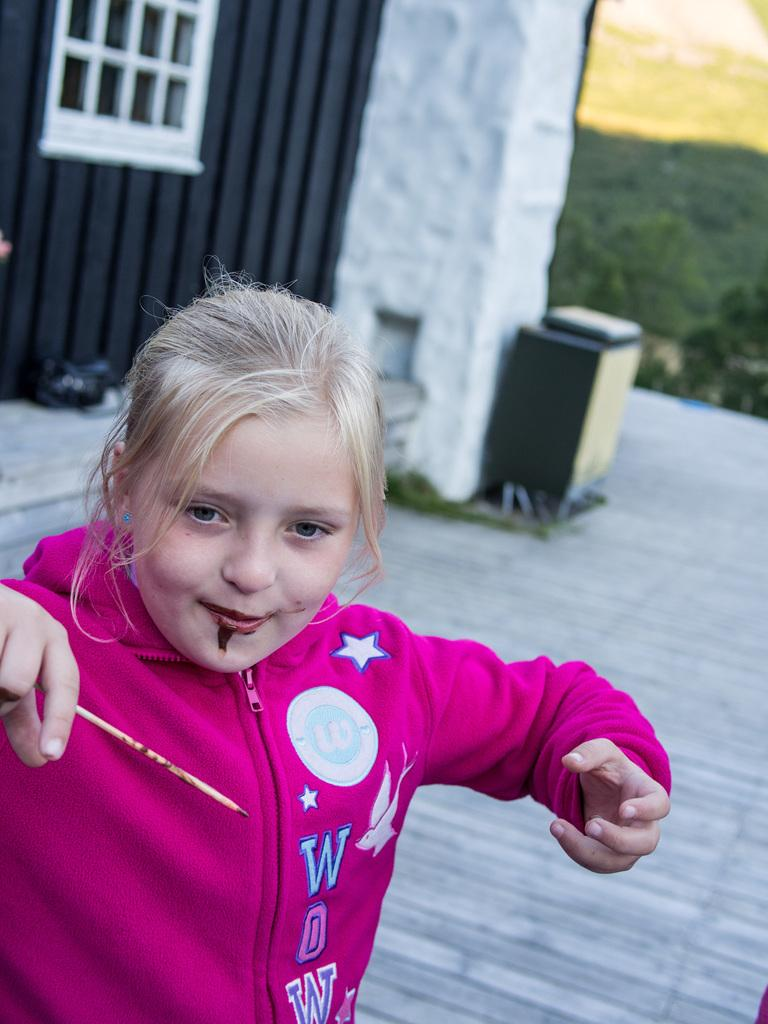<image>
Relay a brief, clear account of the picture shown. A girl in a WDW sweatshirt has paint or food on her chin. 